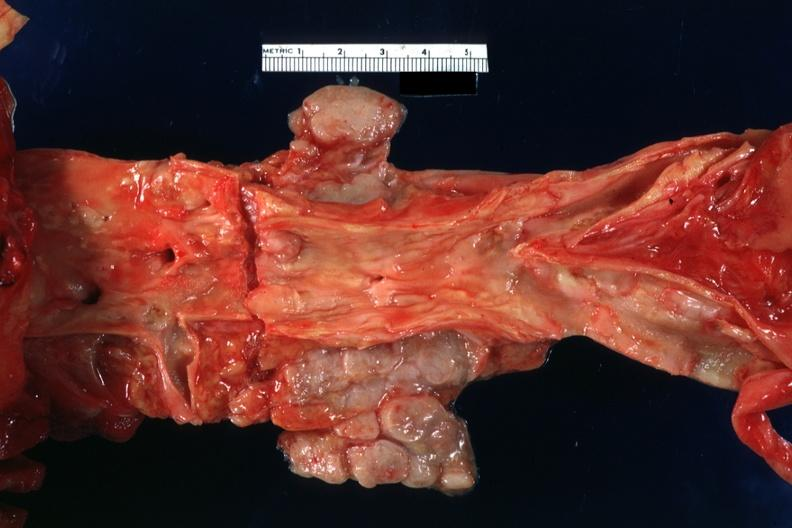what does this image show?
Answer the question using a single word or phrase. Enlarged periaortic nodes with homogeneous tan tumor primary malignant carcinoid in jejunum 